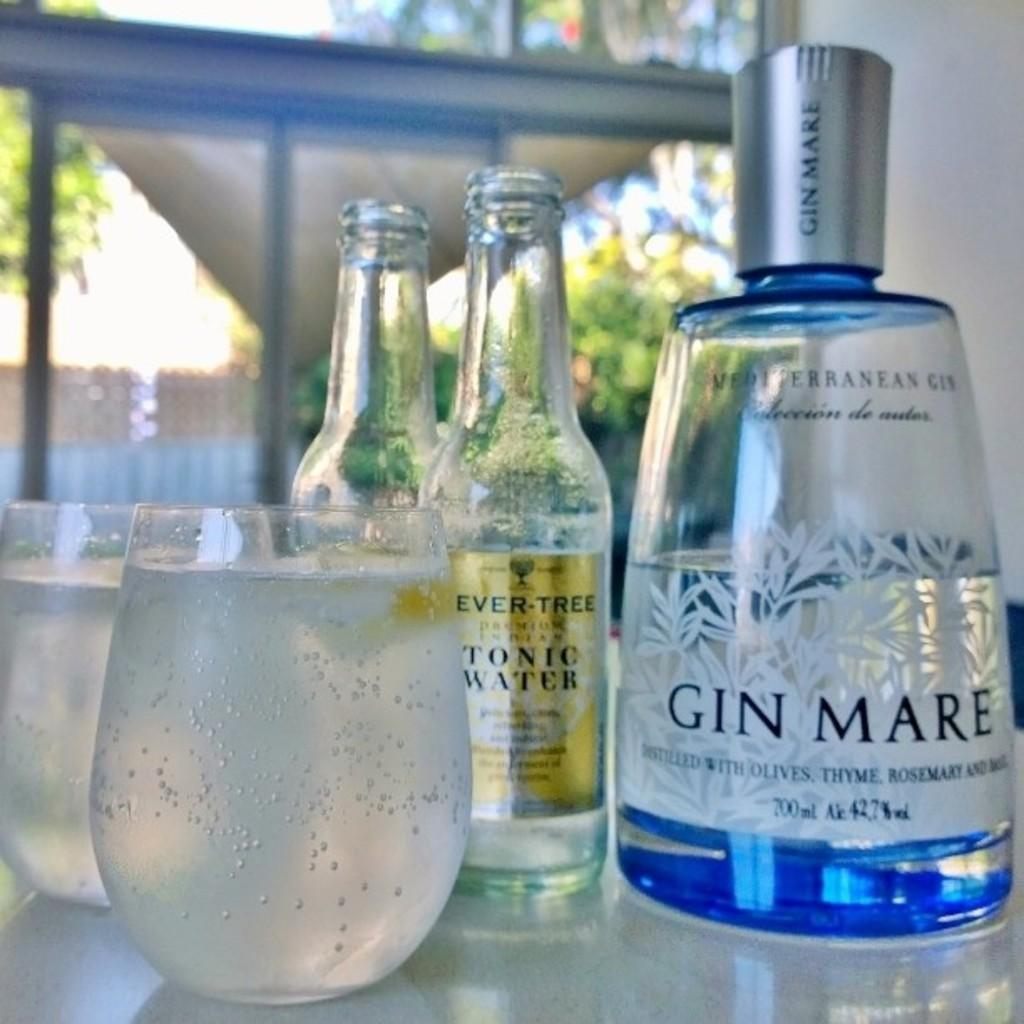<image>
Give a short and clear explanation of the subsequent image. A full glass is next to a bottle of gin and a bottle of tonic water. 